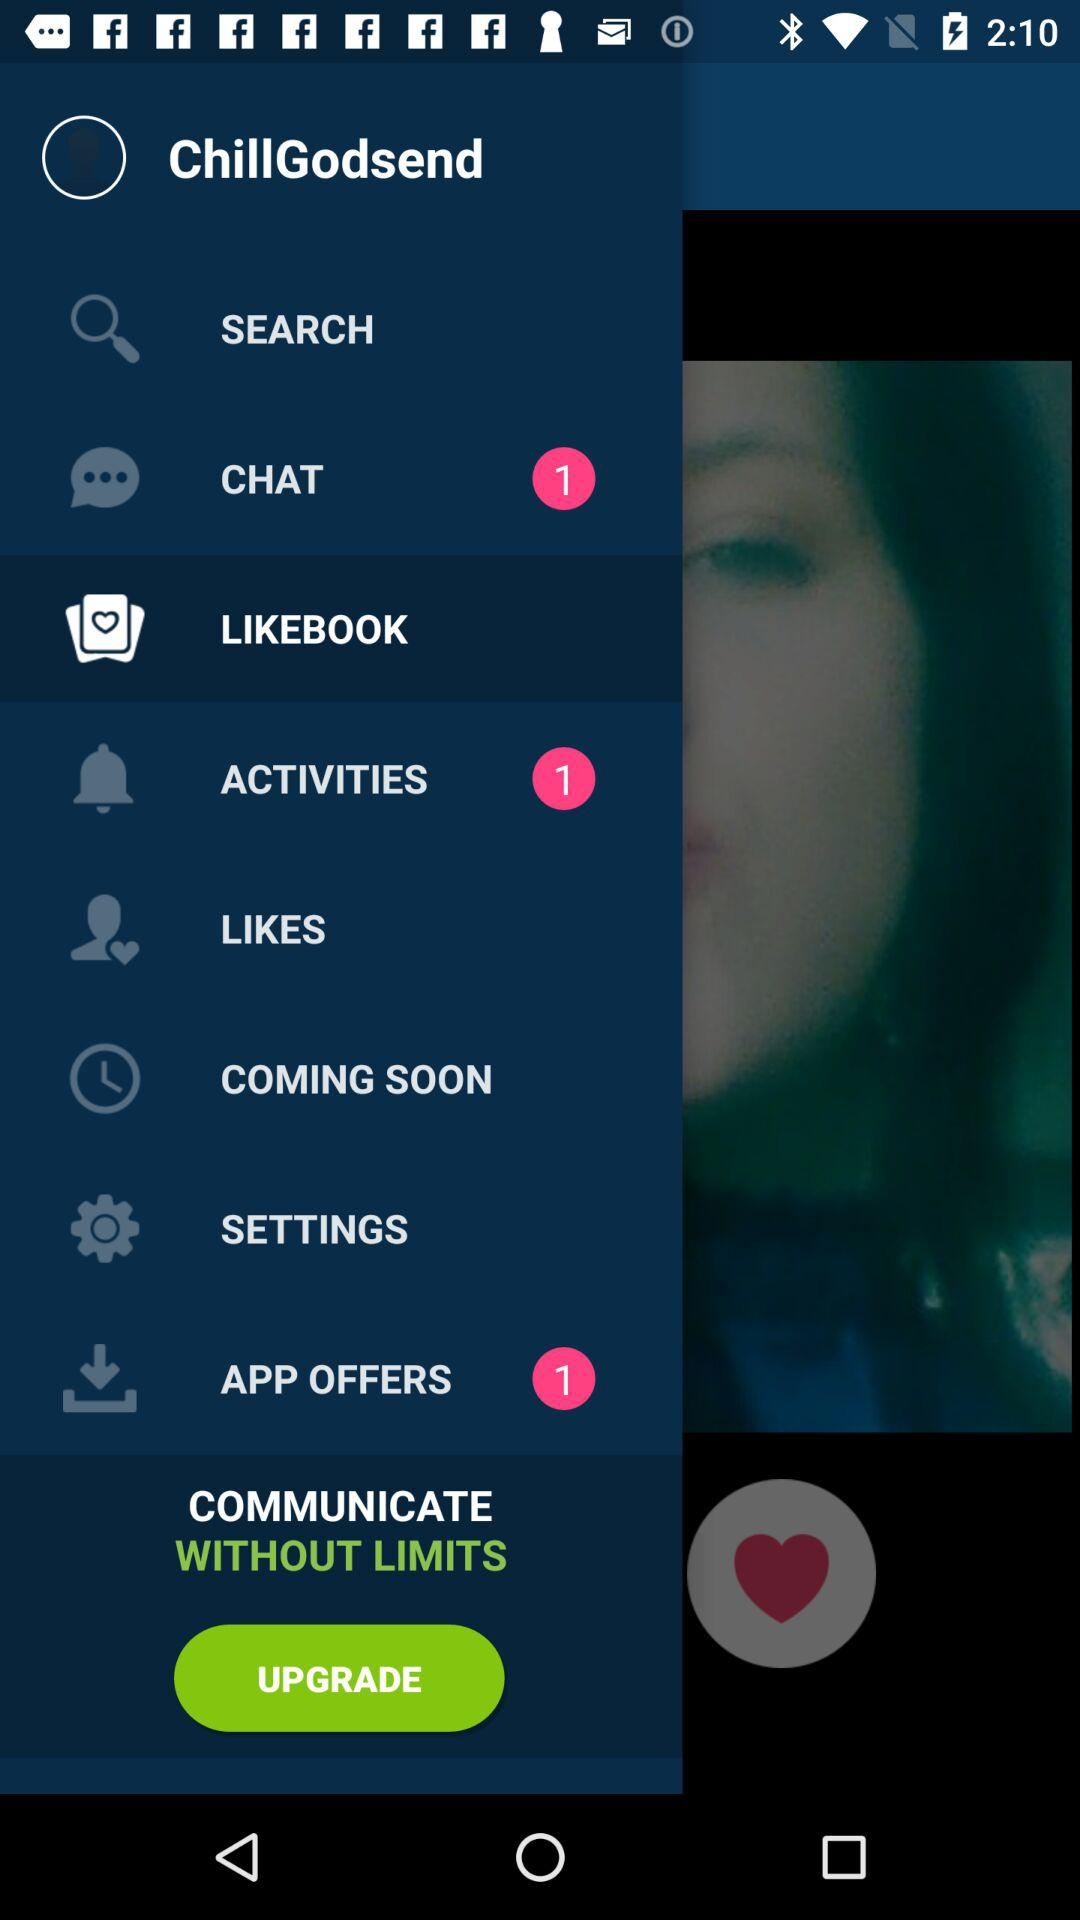How many notifications are pending for "APP OFFERS"? There is 1 notification pending for "APP OFFERS". 